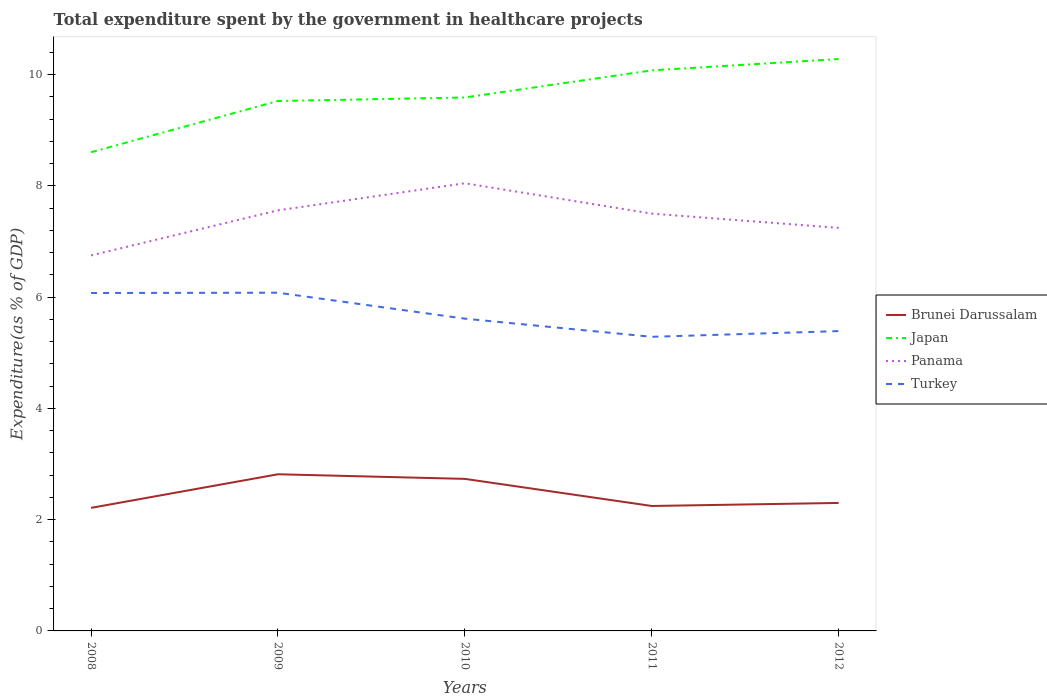Across all years, what is the maximum total expenditure spent by the government in healthcare projects in Panama?
Offer a terse response. 6.75. What is the total total expenditure spent by the government in healthcare projects in Brunei Darussalam in the graph?
Offer a very short reply. 0.08. What is the difference between the highest and the second highest total expenditure spent by the government in healthcare projects in Panama?
Provide a short and direct response. 1.3. Does the graph contain any zero values?
Ensure brevity in your answer.  No. Does the graph contain grids?
Ensure brevity in your answer.  No. How are the legend labels stacked?
Provide a short and direct response. Vertical. What is the title of the graph?
Provide a succinct answer. Total expenditure spent by the government in healthcare projects. What is the label or title of the Y-axis?
Give a very brief answer. Expenditure(as % of GDP). What is the Expenditure(as % of GDP) in Brunei Darussalam in 2008?
Provide a short and direct response. 2.21. What is the Expenditure(as % of GDP) of Japan in 2008?
Offer a very short reply. 8.61. What is the Expenditure(as % of GDP) of Panama in 2008?
Provide a short and direct response. 6.75. What is the Expenditure(as % of GDP) of Turkey in 2008?
Your response must be concise. 6.07. What is the Expenditure(as % of GDP) of Brunei Darussalam in 2009?
Your response must be concise. 2.82. What is the Expenditure(as % of GDP) of Japan in 2009?
Make the answer very short. 9.53. What is the Expenditure(as % of GDP) of Panama in 2009?
Provide a succinct answer. 7.56. What is the Expenditure(as % of GDP) in Turkey in 2009?
Your answer should be compact. 6.08. What is the Expenditure(as % of GDP) of Brunei Darussalam in 2010?
Your response must be concise. 2.73. What is the Expenditure(as % of GDP) of Japan in 2010?
Your response must be concise. 9.59. What is the Expenditure(as % of GDP) in Panama in 2010?
Give a very brief answer. 8.05. What is the Expenditure(as % of GDP) in Turkey in 2010?
Provide a short and direct response. 5.61. What is the Expenditure(as % of GDP) in Brunei Darussalam in 2011?
Make the answer very short. 2.25. What is the Expenditure(as % of GDP) in Japan in 2011?
Your answer should be very brief. 10.08. What is the Expenditure(as % of GDP) of Panama in 2011?
Provide a short and direct response. 7.5. What is the Expenditure(as % of GDP) in Turkey in 2011?
Keep it short and to the point. 5.29. What is the Expenditure(as % of GDP) of Brunei Darussalam in 2012?
Your answer should be very brief. 2.3. What is the Expenditure(as % of GDP) in Japan in 2012?
Give a very brief answer. 10.28. What is the Expenditure(as % of GDP) of Panama in 2012?
Ensure brevity in your answer.  7.25. What is the Expenditure(as % of GDP) of Turkey in 2012?
Offer a very short reply. 5.39. Across all years, what is the maximum Expenditure(as % of GDP) in Brunei Darussalam?
Offer a very short reply. 2.82. Across all years, what is the maximum Expenditure(as % of GDP) in Japan?
Keep it short and to the point. 10.28. Across all years, what is the maximum Expenditure(as % of GDP) in Panama?
Your response must be concise. 8.05. Across all years, what is the maximum Expenditure(as % of GDP) in Turkey?
Provide a succinct answer. 6.08. Across all years, what is the minimum Expenditure(as % of GDP) in Brunei Darussalam?
Your answer should be very brief. 2.21. Across all years, what is the minimum Expenditure(as % of GDP) of Japan?
Your answer should be compact. 8.61. Across all years, what is the minimum Expenditure(as % of GDP) of Panama?
Provide a succinct answer. 6.75. Across all years, what is the minimum Expenditure(as % of GDP) of Turkey?
Your answer should be very brief. 5.29. What is the total Expenditure(as % of GDP) of Brunei Darussalam in the graph?
Give a very brief answer. 12.31. What is the total Expenditure(as % of GDP) of Japan in the graph?
Offer a very short reply. 48.08. What is the total Expenditure(as % of GDP) in Panama in the graph?
Your answer should be very brief. 37.1. What is the total Expenditure(as % of GDP) in Turkey in the graph?
Your answer should be very brief. 28.44. What is the difference between the Expenditure(as % of GDP) of Brunei Darussalam in 2008 and that in 2009?
Your answer should be very brief. -0.6. What is the difference between the Expenditure(as % of GDP) of Japan in 2008 and that in 2009?
Provide a succinct answer. -0.92. What is the difference between the Expenditure(as % of GDP) in Panama in 2008 and that in 2009?
Offer a terse response. -0.81. What is the difference between the Expenditure(as % of GDP) of Turkey in 2008 and that in 2009?
Provide a succinct answer. -0.01. What is the difference between the Expenditure(as % of GDP) of Brunei Darussalam in 2008 and that in 2010?
Your response must be concise. -0.52. What is the difference between the Expenditure(as % of GDP) in Japan in 2008 and that in 2010?
Your answer should be very brief. -0.98. What is the difference between the Expenditure(as % of GDP) in Panama in 2008 and that in 2010?
Provide a succinct answer. -1.3. What is the difference between the Expenditure(as % of GDP) in Turkey in 2008 and that in 2010?
Provide a succinct answer. 0.46. What is the difference between the Expenditure(as % of GDP) in Brunei Darussalam in 2008 and that in 2011?
Keep it short and to the point. -0.03. What is the difference between the Expenditure(as % of GDP) in Japan in 2008 and that in 2011?
Provide a short and direct response. -1.47. What is the difference between the Expenditure(as % of GDP) in Panama in 2008 and that in 2011?
Your answer should be compact. -0.75. What is the difference between the Expenditure(as % of GDP) in Turkey in 2008 and that in 2011?
Provide a short and direct response. 0.79. What is the difference between the Expenditure(as % of GDP) in Brunei Darussalam in 2008 and that in 2012?
Your answer should be very brief. -0.09. What is the difference between the Expenditure(as % of GDP) in Japan in 2008 and that in 2012?
Ensure brevity in your answer.  -1.68. What is the difference between the Expenditure(as % of GDP) of Panama in 2008 and that in 2012?
Offer a very short reply. -0.5. What is the difference between the Expenditure(as % of GDP) of Turkey in 2008 and that in 2012?
Make the answer very short. 0.69. What is the difference between the Expenditure(as % of GDP) of Brunei Darussalam in 2009 and that in 2010?
Offer a terse response. 0.08. What is the difference between the Expenditure(as % of GDP) in Japan in 2009 and that in 2010?
Your response must be concise. -0.06. What is the difference between the Expenditure(as % of GDP) in Panama in 2009 and that in 2010?
Ensure brevity in your answer.  -0.49. What is the difference between the Expenditure(as % of GDP) of Turkey in 2009 and that in 2010?
Ensure brevity in your answer.  0.47. What is the difference between the Expenditure(as % of GDP) in Brunei Darussalam in 2009 and that in 2011?
Your answer should be very brief. 0.57. What is the difference between the Expenditure(as % of GDP) of Japan in 2009 and that in 2011?
Make the answer very short. -0.55. What is the difference between the Expenditure(as % of GDP) in Panama in 2009 and that in 2011?
Your response must be concise. 0.06. What is the difference between the Expenditure(as % of GDP) of Turkey in 2009 and that in 2011?
Offer a very short reply. 0.79. What is the difference between the Expenditure(as % of GDP) in Brunei Darussalam in 2009 and that in 2012?
Provide a succinct answer. 0.52. What is the difference between the Expenditure(as % of GDP) of Japan in 2009 and that in 2012?
Keep it short and to the point. -0.75. What is the difference between the Expenditure(as % of GDP) of Panama in 2009 and that in 2012?
Offer a terse response. 0.32. What is the difference between the Expenditure(as % of GDP) in Turkey in 2009 and that in 2012?
Provide a short and direct response. 0.69. What is the difference between the Expenditure(as % of GDP) in Brunei Darussalam in 2010 and that in 2011?
Ensure brevity in your answer.  0.49. What is the difference between the Expenditure(as % of GDP) of Japan in 2010 and that in 2011?
Keep it short and to the point. -0.49. What is the difference between the Expenditure(as % of GDP) in Panama in 2010 and that in 2011?
Offer a terse response. 0.55. What is the difference between the Expenditure(as % of GDP) of Turkey in 2010 and that in 2011?
Keep it short and to the point. 0.33. What is the difference between the Expenditure(as % of GDP) of Brunei Darussalam in 2010 and that in 2012?
Your answer should be compact. 0.43. What is the difference between the Expenditure(as % of GDP) of Japan in 2010 and that in 2012?
Offer a terse response. -0.69. What is the difference between the Expenditure(as % of GDP) in Panama in 2010 and that in 2012?
Your answer should be compact. 0.8. What is the difference between the Expenditure(as % of GDP) in Turkey in 2010 and that in 2012?
Give a very brief answer. 0.22. What is the difference between the Expenditure(as % of GDP) in Brunei Darussalam in 2011 and that in 2012?
Your response must be concise. -0.05. What is the difference between the Expenditure(as % of GDP) in Japan in 2011 and that in 2012?
Offer a terse response. -0.2. What is the difference between the Expenditure(as % of GDP) in Panama in 2011 and that in 2012?
Provide a short and direct response. 0.26. What is the difference between the Expenditure(as % of GDP) in Turkey in 2011 and that in 2012?
Your answer should be very brief. -0.1. What is the difference between the Expenditure(as % of GDP) of Brunei Darussalam in 2008 and the Expenditure(as % of GDP) of Japan in 2009?
Your response must be concise. -7.31. What is the difference between the Expenditure(as % of GDP) of Brunei Darussalam in 2008 and the Expenditure(as % of GDP) of Panama in 2009?
Offer a very short reply. -5.35. What is the difference between the Expenditure(as % of GDP) in Brunei Darussalam in 2008 and the Expenditure(as % of GDP) in Turkey in 2009?
Make the answer very short. -3.87. What is the difference between the Expenditure(as % of GDP) of Japan in 2008 and the Expenditure(as % of GDP) of Panama in 2009?
Provide a short and direct response. 1.04. What is the difference between the Expenditure(as % of GDP) in Japan in 2008 and the Expenditure(as % of GDP) in Turkey in 2009?
Your answer should be compact. 2.53. What is the difference between the Expenditure(as % of GDP) of Panama in 2008 and the Expenditure(as % of GDP) of Turkey in 2009?
Provide a short and direct response. 0.67. What is the difference between the Expenditure(as % of GDP) in Brunei Darussalam in 2008 and the Expenditure(as % of GDP) in Japan in 2010?
Your response must be concise. -7.38. What is the difference between the Expenditure(as % of GDP) in Brunei Darussalam in 2008 and the Expenditure(as % of GDP) in Panama in 2010?
Give a very brief answer. -5.83. What is the difference between the Expenditure(as % of GDP) of Brunei Darussalam in 2008 and the Expenditure(as % of GDP) of Turkey in 2010?
Make the answer very short. -3.4. What is the difference between the Expenditure(as % of GDP) in Japan in 2008 and the Expenditure(as % of GDP) in Panama in 2010?
Your answer should be compact. 0.56. What is the difference between the Expenditure(as % of GDP) in Japan in 2008 and the Expenditure(as % of GDP) in Turkey in 2010?
Offer a very short reply. 2.99. What is the difference between the Expenditure(as % of GDP) of Panama in 2008 and the Expenditure(as % of GDP) of Turkey in 2010?
Give a very brief answer. 1.14. What is the difference between the Expenditure(as % of GDP) of Brunei Darussalam in 2008 and the Expenditure(as % of GDP) of Japan in 2011?
Offer a very short reply. -7.86. What is the difference between the Expenditure(as % of GDP) of Brunei Darussalam in 2008 and the Expenditure(as % of GDP) of Panama in 2011?
Your answer should be compact. -5.29. What is the difference between the Expenditure(as % of GDP) in Brunei Darussalam in 2008 and the Expenditure(as % of GDP) in Turkey in 2011?
Ensure brevity in your answer.  -3.07. What is the difference between the Expenditure(as % of GDP) of Japan in 2008 and the Expenditure(as % of GDP) of Panama in 2011?
Keep it short and to the point. 1.1. What is the difference between the Expenditure(as % of GDP) of Japan in 2008 and the Expenditure(as % of GDP) of Turkey in 2011?
Offer a terse response. 3.32. What is the difference between the Expenditure(as % of GDP) of Panama in 2008 and the Expenditure(as % of GDP) of Turkey in 2011?
Offer a terse response. 1.46. What is the difference between the Expenditure(as % of GDP) of Brunei Darussalam in 2008 and the Expenditure(as % of GDP) of Japan in 2012?
Keep it short and to the point. -8.07. What is the difference between the Expenditure(as % of GDP) in Brunei Darussalam in 2008 and the Expenditure(as % of GDP) in Panama in 2012?
Your response must be concise. -5.03. What is the difference between the Expenditure(as % of GDP) in Brunei Darussalam in 2008 and the Expenditure(as % of GDP) in Turkey in 2012?
Give a very brief answer. -3.18. What is the difference between the Expenditure(as % of GDP) in Japan in 2008 and the Expenditure(as % of GDP) in Panama in 2012?
Give a very brief answer. 1.36. What is the difference between the Expenditure(as % of GDP) in Japan in 2008 and the Expenditure(as % of GDP) in Turkey in 2012?
Your answer should be compact. 3.22. What is the difference between the Expenditure(as % of GDP) in Panama in 2008 and the Expenditure(as % of GDP) in Turkey in 2012?
Keep it short and to the point. 1.36. What is the difference between the Expenditure(as % of GDP) of Brunei Darussalam in 2009 and the Expenditure(as % of GDP) of Japan in 2010?
Keep it short and to the point. -6.77. What is the difference between the Expenditure(as % of GDP) in Brunei Darussalam in 2009 and the Expenditure(as % of GDP) in Panama in 2010?
Provide a succinct answer. -5.23. What is the difference between the Expenditure(as % of GDP) in Brunei Darussalam in 2009 and the Expenditure(as % of GDP) in Turkey in 2010?
Give a very brief answer. -2.8. What is the difference between the Expenditure(as % of GDP) of Japan in 2009 and the Expenditure(as % of GDP) of Panama in 2010?
Provide a short and direct response. 1.48. What is the difference between the Expenditure(as % of GDP) in Japan in 2009 and the Expenditure(as % of GDP) in Turkey in 2010?
Your answer should be compact. 3.91. What is the difference between the Expenditure(as % of GDP) in Panama in 2009 and the Expenditure(as % of GDP) in Turkey in 2010?
Keep it short and to the point. 1.95. What is the difference between the Expenditure(as % of GDP) of Brunei Darussalam in 2009 and the Expenditure(as % of GDP) of Japan in 2011?
Make the answer very short. -7.26. What is the difference between the Expenditure(as % of GDP) in Brunei Darussalam in 2009 and the Expenditure(as % of GDP) in Panama in 2011?
Provide a succinct answer. -4.69. What is the difference between the Expenditure(as % of GDP) in Brunei Darussalam in 2009 and the Expenditure(as % of GDP) in Turkey in 2011?
Your response must be concise. -2.47. What is the difference between the Expenditure(as % of GDP) of Japan in 2009 and the Expenditure(as % of GDP) of Panama in 2011?
Ensure brevity in your answer.  2.02. What is the difference between the Expenditure(as % of GDP) in Japan in 2009 and the Expenditure(as % of GDP) in Turkey in 2011?
Make the answer very short. 4.24. What is the difference between the Expenditure(as % of GDP) in Panama in 2009 and the Expenditure(as % of GDP) in Turkey in 2011?
Make the answer very short. 2.27. What is the difference between the Expenditure(as % of GDP) of Brunei Darussalam in 2009 and the Expenditure(as % of GDP) of Japan in 2012?
Offer a very short reply. -7.46. What is the difference between the Expenditure(as % of GDP) in Brunei Darussalam in 2009 and the Expenditure(as % of GDP) in Panama in 2012?
Offer a very short reply. -4.43. What is the difference between the Expenditure(as % of GDP) in Brunei Darussalam in 2009 and the Expenditure(as % of GDP) in Turkey in 2012?
Your answer should be very brief. -2.57. What is the difference between the Expenditure(as % of GDP) of Japan in 2009 and the Expenditure(as % of GDP) of Panama in 2012?
Offer a terse response. 2.28. What is the difference between the Expenditure(as % of GDP) of Japan in 2009 and the Expenditure(as % of GDP) of Turkey in 2012?
Your answer should be very brief. 4.14. What is the difference between the Expenditure(as % of GDP) of Panama in 2009 and the Expenditure(as % of GDP) of Turkey in 2012?
Keep it short and to the point. 2.17. What is the difference between the Expenditure(as % of GDP) of Brunei Darussalam in 2010 and the Expenditure(as % of GDP) of Japan in 2011?
Your response must be concise. -7.34. What is the difference between the Expenditure(as % of GDP) of Brunei Darussalam in 2010 and the Expenditure(as % of GDP) of Panama in 2011?
Your answer should be compact. -4.77. What is the difference between the Expenditure(as % of GDP) of Brunei Darussalam in 2010 and the Expenditure(as % of GDP) of Turkey in 2011?
Provide a succinct answer. -2.55. What is the difference between the Expenditure(as % of GDP) of Japan in 2010 and the Expenditure(as % of GDP) of Panama in 2011?
Your response must be concise. 2.09. What is the difference between the Expenditure(as % of GDP) of Japan in 2010 and the Expenditure(as % of GDP) of Turkey in 2011?
Provide a short and direct response. 4.3. What is the difference between the Expenditure(as % of GDP) in Panama in 2010 and the Expenditure(as % of GDP) in Turkey in 2011?
Provide a succinct answer. 2.76. What is the difference between the Expenditure(as % of GDP) in Brunei Darussalam in 2010 and the Expenditure(as % of GDP) in Japan in 2012?
Your answer should be compact. -7.55. What is the difference between the Expenditure(as % of GDP) in Brunei Darussalam in 2010 and the Expenditure(as % of GDP) in Panama in 2012?
Offer a terse response. -4.51. What is the difference between the Expenditure(as % of GDP) in Brunei Darussalam in 2010 and the Expenditure(as % of GDP) in Turkey in 2012?
Give a very brief answer. -2.66. What is the difference between the Expenditure(as % of GDP) in Japan in 2010 and the Expenditure(as % of GDP) in Panama in 2012?
Your answer should be very brief. 2.34. What is the difference between the Expenditure(as % of GDP) in Japan in 2010 and the Expenditure(as % of GDP) in Turkey in 2012?
Make the answer very short. 4.2. What is the difference between the Expenditure(as % of GDP) in Panama in 2010 and the Expenditure(as % of GDP) in Turkey in 2012?
Offer a terse response. 2.66. What is the difference between the Expenditure(as % of GDP) in Brunei Darussalam in 2011 and the Expenditure(as % of GDP) in Japan in 2012?
Offer a terse response. -8.03. What is the difference between the Expenditure(as % of GDP) in Brunei Darussalam in 2011 and the Expenditure(as % of GDP) in Panama in 2012?
Provide a short and direct response. -5. What is the difference between the Expenditure(as % of GDP) of Brunei Darussalam in 2011 and the Expenditure(as % of GDP) of Turkey in 2012?
Make the answer very short. -3.14. What is the difference between the Expenditure(as % of GDP) in Japan in 2011 and the Expenditure(as % of GDP) in Panama in 2012?
Make the answer very short. 2.83. What is the difference between the Expenditure(as % of GDP) of Japan in 2011 and the Expenditure(as % of GDP) of Turkey in 2012?
Provide a succinct answer. 4.69. What is the difference between the Expenditure(as % of GDP) in Panama in 2011 and the Expenditure(as % of GDP) in Turkey in 2012?
Keep it short and to the point. 2.11. What is the average Expenditure(as % of GDP) in Brunei Darussalam per year?
Provide a short and direct response. 2.46. What is the average Expenditure(as % of GDP) of Japan per year?
Your answer should be very brief. 9.62. What is the average Expenditure(as % of GDP) of Panama per year?
Provide a succinct answer. 7.42. What is the average Expenditure(as % of GDP) of Turkey per year?
Offer a very short reply. 5.69. In the year 2008, what is the difference between the Expenditure(as % of GDP) in Brunei Darussalam and Expenditure(as % of GDP) in Japan?
Provide a short and direct response. -6.39. In the year 2008, what is the difference between the Expenditure(as % of GDP) in Brunei Darussalam and Expenditure(as % of GDP) in Panama?
Provide a succinct answer. -4.54. In the year 2008, what is the difference between the Expenditure(as % of GDP) of Brunei Darussalam and Expenditure(as % of GDP) of Turkey?
Offer a terse response. -3.86. In the year 2008, what is the difference between the Expenditure(as % of GDP) of Japan and Expenditure(as % of GDP) of Panama?
Provide a succinct answer. 1.85. In the year 2008, what is the difference between the Expenditure(as % of GDP) in Japan and Expenditure(as % of GDP) in Turkey?
Your answer should be compact. 2.53. In the year 2008, what is the difference between the Expenditure(as % of GDP) of Panama and Expenditure(as % of GDP) of Turkey?
Offer a terse response. 0.68. In the year 2009, what is the difference between the Expenditure(as % of GDP) in Brunei Darussalam and Expenditure(as % of GDP) in Japan?
Give a very brief answer. -6.71. In the year 2009, what is the difference between the Expenditure(as % of GDP) of Brunei Darussalam and Expenditure(as % of GDP) of Panama?
Provide a succinct answer. -4.74. In the year 2009, what is the difference between the Expenditure(as % of GDP) of Brunei Darussalam and Expenditure(as % of GDP) of Turkey?
Offer a very short reply. -3.26. In the year 2009, what is the difference between the Expenditure(as % of GDP) of Japan and Expenditure(as % of GDP) of Panama?
Your answer should be compact. 1.97. In the year 2009, what is the difference between the Expenditure(as % of GDP) in Japan and Expenditure(as % of GDP) in Turkey?
Give a very brief answer. 3.45. In the year 2009, what is the difference between the Expenditure(as % of GDP) in Panama and Expenditure(as % of GDP) in Turkey?
Offer a terse response. 1.48. In the year 2010, what is the difference between the Expenditure(as % of GDP) of Brunei Darussalam and Expenditure(as % of GDP) of Japan?
Your answer should be very brief. -6.86. In the year 2010, what is the difference between the Expenditure(as % of GDP) of Brunei Darussalam and Expenditure(as % of GDP) of Panama?
Provide a short and direct response. -5.31. In the year 2010, what is the difference between the Expenditure(as % of GDP) of Brunei Darussalam and Expenditure(as % of GDP) of Turkey?
Ensure brevity in your answer.  -2.88. In the year 2010, what is the difference between the Expenditure(as % of GDP) of Japan and Expenditure(as % of GDP) of Panama?
Keep it short and to the point. 1.54. In the year 2010, what is the difference between the Expenditure(as % of GDP) of Japan and Expenditure(as % of GDP) of Turkey?
Make the answer very short. 3.98. In the year 2010, what is the difference between the Expenditure(as % of GDP) of Panama and Expenditure(as % of GDP) of Turkey?
Give a very brief answer. 2.43. In the year 2011, what is the difference between the Expenditure(as % of GDP) of Brunei Darussalam and Expenditure(as % of GDP) of Japan?
Offer a terse response. -7.83. In the year 2011, what is the difference between the Expenditure(as % of GDP) in Brunei Darussalam and Expenditure(as % of GDP) in Panama?
Make the answer very short. -5.26. In the year 2011, what is the difference between the Expenditure(as % of GDP) of Brunei Darussalam and Expenditure(as % of GDP) of Turkey?
Your answer should be compact. -3.04. In the year 2011, what is the difference between the Expenditure(as % of GDP) of Japan and Expenditure(as % of GDP) of Panama?
Provide a succinct answer. 2.58. In the year 2011, what is the difference between the Expenditure(as % of GDP) of Japan and Expenditure(as % of GDP) of Turkey?
Provide a short and direct response. 4.79. In the year 2011, what is the difference between the Expenditure(as % of GDP) in Panama and Expenditure(as % of GDP) in Turkey?
Give a very brief answer. 2.21. In the year 2012, what is the difference between the Expenditure(as % of GDP) of Brunei Darussalam and Expenditure(as % of GDP) of Japan?
Keep it short and to the point. -7.98. In the year 2012, what is the difference between the Expenditure(as % of GDP) of Brunei Darussalam and Expenditure(as % of GDP) of Panama?
Your response must be concise. -4.94. In the year 2012, what is the difference between the Expenditure(as % of GDP) of Brunei Darussalam and Expenditure(as % of GDP) of Turkey?
Provide a succinct answer. -3.09. In the year 2012, what is the difference between the Expenditure(as % of GDP) of Japan and Expenditure(as % of GDP) of Panama?
Your response must be concise. 3.04. In the year 2012, what is the difference between the Expenditure(as % of GDP) in Japan and Expenditure(as % of GDP) in Turkey?
Offer a terse response. 4.89. In the year 2012, what is the difference between the Expenditure(as % of GDP) of Panama and Expenditure(as % of GDP) of Turkey?
Your response must be concise. 1.86. What is the ratio of the Expenditure(as % of GDP) of Brunei Darussalam in 2008 to that in 2009?
Your answer should be very brief. 0.79. What is the ratio of the Expenditure(as % of GDP) of Japan in 2008 to that in 2009?
Offer a terse response. 0.9. What is the ratio of the Expenditure(as % of GDP) in Panama in 2008 to that in 2009?
Keep it short and to the point. 0.89. What is the ratio of the Expenditure(as % of GDP) in Turkey in 2008 to that in 2009?
Offer a terse response. 1. What is the ratio of the Expenditure(as % of GDP) of Brunei Darussalam in 2008 to that in 2010?
Keep it short and to the point. 0.81. What is the ratio of the Expenditure(as % of GDP) in Japan in 2008 to that in 2010?
Offer a very short reply. 0.9. What is the ratio of the Expenditure(as % of GDP) in Panama in 2008 to that in 2010?
Your response must be concise. 0.84. What is the ratio of the Expenditure(as % of GDP) in Turkey in 2008 to that in 2010?
Give a very brief answer. 1.08. What is the ratio of the Expenditure(as % of GDP) of Japan in 2008 to that in 2011?
Your answer should be compact. 0.85. What is the ratio of the Expenditure(as % of GDP) of Panama in 2008 to that in 2011?
Your answer should be compact. 0.9. What is the ratio of the Expenditure(as % of GDP) of Turkey in 2008 to that in 2011?
Make the answer very short. 1.15. What is the ratio of the Expenditure(as % of GDP) of Brunei Darussalam in 2008 to that in 2012?
Offer a very short reply. 0.96. What is the ratio of the Expenditure(as % of GDP) in Japan in 2008 to that in 2012?
Your answer should be very brief. 0.84. What is the ratio of the Expenditure(as % of GDP) of Panama in 2008 to that in 2012?
Ensure brevity in your answer.  0.93. What is the ratio of the Expenditure(as % of GDP) in Turkey in 2008 to that in 2012?
Your answer should be very brief. 1.13. What is the ratio of the Expenditure(as % of GDP) of Brunei Darussalam in 2009 to that in 2010?
Ensure brevity in your answer.  1.03. What is the ratio of the Expenditure(as % of GDP) of Japan in 2009 to that in 2010?
Give a very brief answer. 0.99. What is the ratio of the Expenditure(as % of GDP) in Panama in 2009 to that in 2010?
Provide a short and direct response. 0.94. What is the ratio of the Expenditure(as % of GDP) of Turkey in 2009 to that in 2010?
Give a very brief answer. 1.08. What is the ratio of the Expenditure(as % of GDP) of Brunei Darussalam in 2009 to that in 2011?
Your response must be concise. 1.25. What is the ratio of the Expenditure(as % of GDP) of Japan in 2009 to that in 2011?
Provide a short and direct response. 0.95. What is the ratio of the Expenditure(as % of GDP) of Turkey in 2009 to that in 2011?
Provide a short and direct response. 1.15. What is the ratio of the Expenditure(as % of GDP) in Brunei Darussalam in 2009 to that in 2012?
Give a very brief answer. 1.22. What is the ratio of the Expenditure(as % of GDP) of Japan in 2009 to that in 2012?
Your answer should be compact. 0.93. What is the ratio of the Expenditure(as % of GDP) of Panama in 2009 to that in 2012?
Your answer should be very brief. 1.04. What is the ratio of the Expenditure(as % of GDP) of Turkey in 2009 to that in 2012?
Give a very brief answer. 1.13. What is the ratio of the Expenditure(as % of GDP) of Brunei Darussalam in 2010 to that in 2011?
Your response must be concise. 1.22. What is the ratio of the Expenditure(as % of GDP) in Japan in 2010 to that in 2011?
Keep it short and to the point. 0.95. What is the ratio of the Expenditure(as % of GDP) in Panama in 2010 to that in 2011?
Provide a short and direct response. 1.07. What is the ratio of the Expenditure(as % of GDP) of Turkey in 2010 to that in 2011?
Offer a terse response. 1.06. What is the ratio of the Expenditure(as % of GDP) of Brunei Darussalam in 2010 to that in 2012?
Your answer should be compact. 1.19. What is the ratio of the Expenditure(as % of GDP) in Japan in 2010 to that in 2012?
Keep it short and to the point. 0.93. What is the ratio of the Expenditure(as % of GDP) of Panama in 2010 to that in 2012?
Your answer should be very brief. 1.11. What is the ratio of the Expenditure(as % of GDP) of Turkey in 2010 to that in 2012?
Offer a very short reply. 1.04. What is the ratio of the Expenditure(as % of GDP) in Brunei Darussalam in 2011 to that in 2012?
Make the answer very short. 0.98. What is the ratio of the Expenditure(as % of GDP) in Japan in 2011 to that in 2012?
Ensure brevity in your answer.  0.98. What is the ratio of the Expenditure(as % of GDP) in Panama in 2011 to that in 2012?
Provide a short and direct response. 1.04. What is the ratio of the Expenditure(as % of GDP) of Turkey in 2011 to that in 2012?
Offer a terse response. 0.98. What is the difference between the highest and the second highest Expenditure(as % of GDP) of Brunei Darussalam?
Provide a short and direct response. 0.08. What is the difference between the highest and the second highest Expenditure(as % of GDP) in Japan?
Give a very brief answer. 0.2. What is the difference between the highest and the second highest Expenditure(as % of GDP) in Panama?
Provide a short and direct response. 0.49. What is the difference between the highest and the second highest Expenditure(as % of GDP) in Turkey?
Your answer should be very brief. 0.01. What is the difference between the highest and the lowest Expenditure(as % of GDP) in Brunei Darussalam?
Make the answer very short. 0.6. What is the difference between the highest and the lowest Expenditure(as % of GDP) in Japan?
Make the answer very short. 1.68. What is the difference between the highest and the lowest Expenditure(as % of GDP) of Panama?
Provide a succinct answer. 1.3. What is the difference between the highest and the lowest Expenditure(as % of GDP) of Turkey?
Provide a short and direct response. 0.79. 